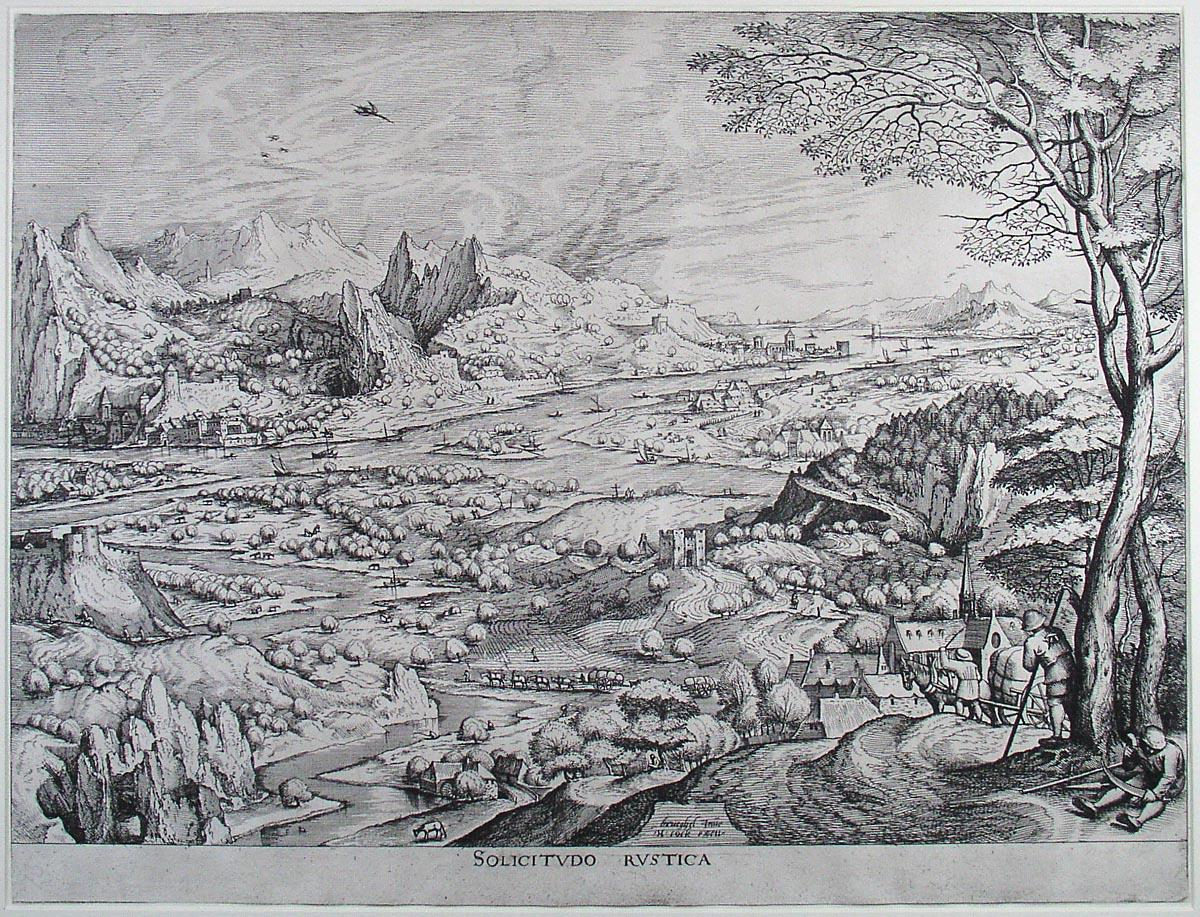What kind of stories could be told about the castle visible in the distance? The castle, standing proudly in the distance, is a repository of countless legends and tales. It is said that a noble family once resided there, ruling the surrounding lands with a just and benevolent spirit. Tales of knights returning victorious from faraway battles, bringing with them stories of valor and adventure, are often told around the village fires. There are whispers of hidden treasures buried deep within the castle’s basement, protected by ancient spells and the spirits of long-departed guardians. The grand halls and labyrinthine corridors have witnessed grand feasts and hushed conspiracies alike, all etched into the very stones of the castle walls. On stormy nights, some villagers still claim to hear the echoes of distant music and laughter, the spectral remnants of a bygone era. Could you weave a fantastical tale involving the castle, the river, and the mountains? In a time lost to history, the castle by the river was the heart of a vibrant kingdom nestled among the protective embrace of the great mountains. Legend spoke of an enchanted river that flowed with waters of crystal clarity, possessing the power to heal any ailment and grant wisdom to those pure of heart. The mountains, with their hidden pathways and formidable peaks, were home to mystical creatures and ancient guardians who watched over the lands. One fateful day, the kingdom faced a dire threat from a dark sorcerer who sought to drain the river of its magical essence and enslave the mountains' creatures for his nefarious purposes. A young, courageous knight from the castle, guided by the spirits of the mountains and armed with a blade forged from the river’s sacred waters, embarked on a perilous quest to thwart the sorcerer’s plans. The knight’s journey led him through treacherous terrains, where he forged alliances with the mystical beings of the mountains and discovered hidden sources of strength within himself. In an epic confrontation by the river's source, the knight managed to vanquish the sorcerer, restoring peace and balance to the kingdom. To this day, the tales of his bravery and the enduring harmony between the castle, the river, and the mountains are celebrated in song and story, a testament to the boundless wonders of their world. 